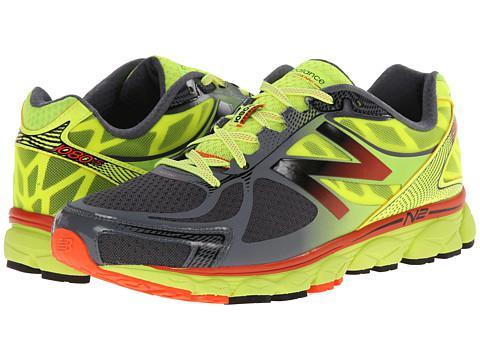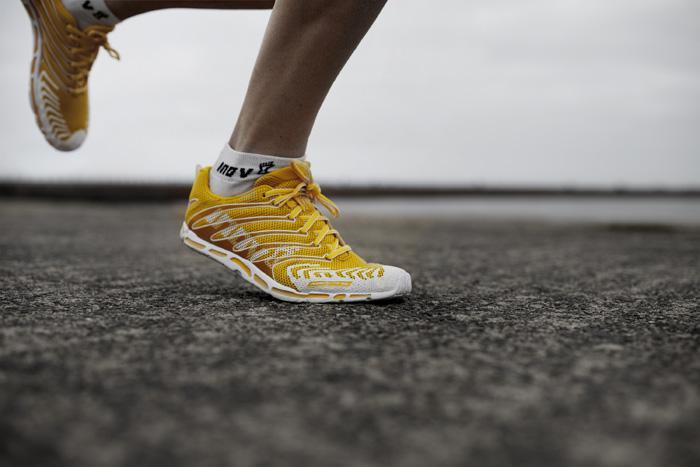The first image is the image on the left, the second image is the image on the right. Assess this claim about the two images: "There are more than two shoes pictured.". Correct or not? Answer yes or no. Yes. The first image is the image on the left, the second image is the image on the right. Assess this claim about the two images: "The left image contains a matched pair of unworn sneakers, and the right image features a sneaker that shares some of the color of the lefthand sneaker.". Correct or not? Answer yes or no. Yes. 